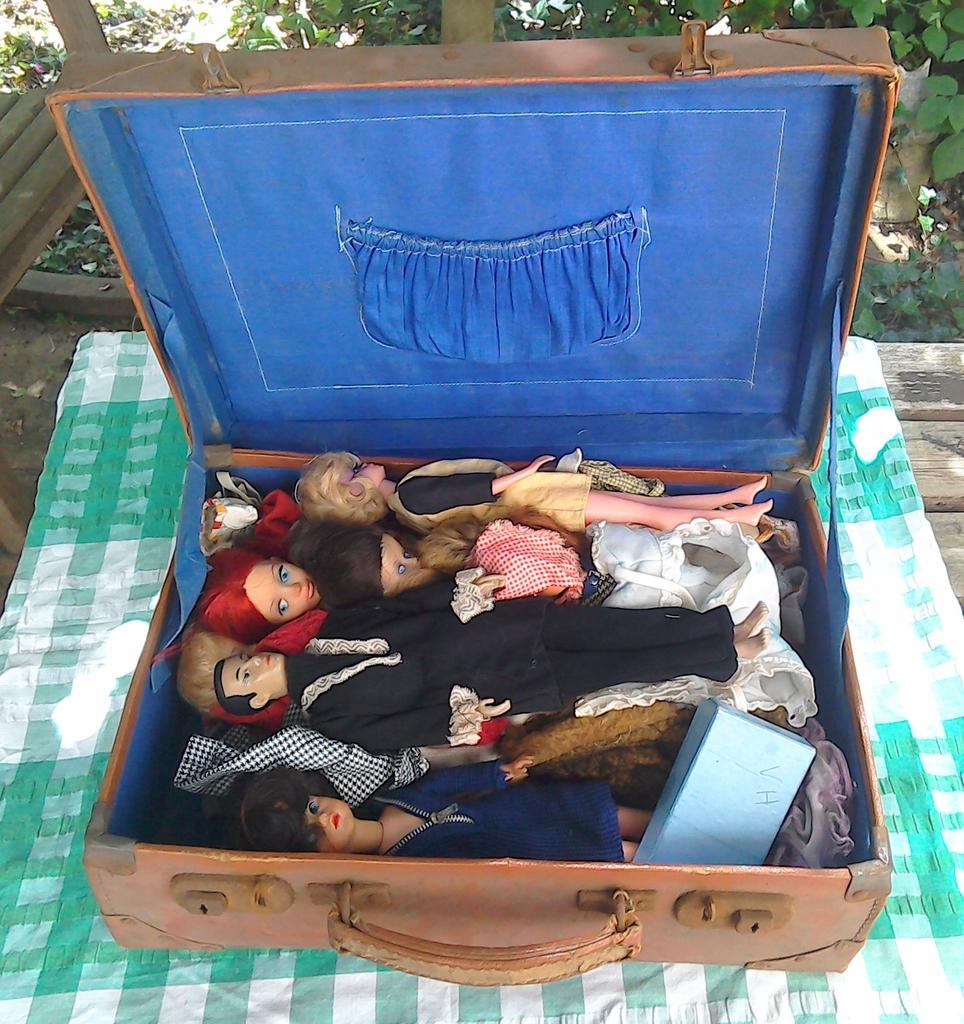What object can be seen in the image that is typically used for carrying items? There is a briefcase in the image. What is inside the briefcase? There are toys inside the briefcase. What type of material is visible in the image? There is cloth visible in the image. What can be seen in the distance in the image? There are trees in the background of the image. What color is the curtain hanging in the image? There is no curtain present in the image. How much silver is visible in the image? There is no silver present in the image. 